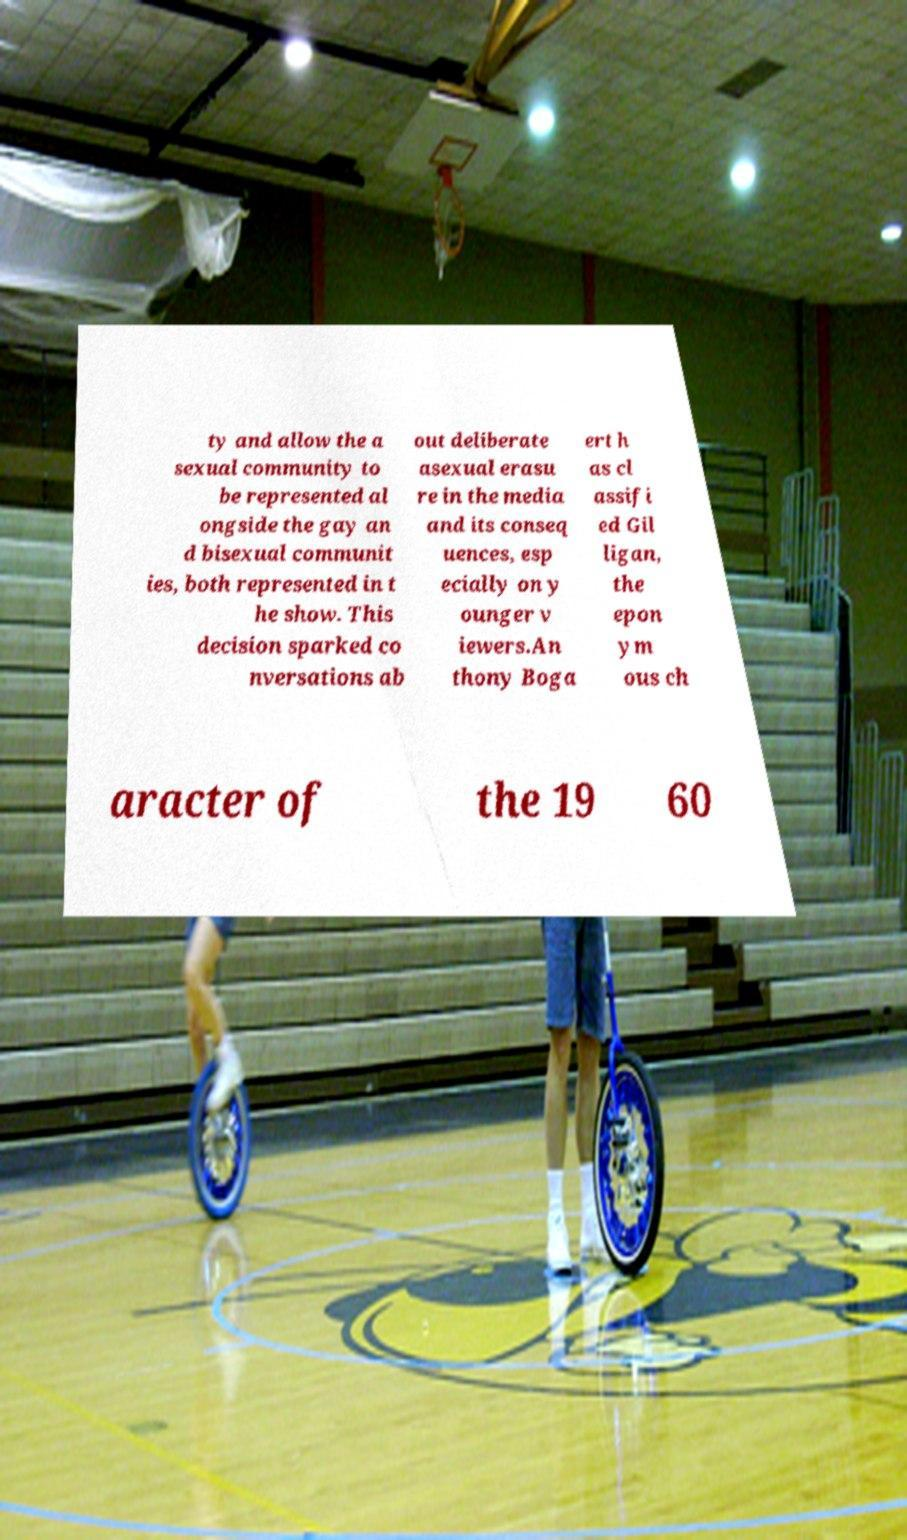What messages or text are displayed in this image? I need them in a readable, typed format. ty and allow the a sexual community to be represented al ongside the gay an d bisexual communit ies, both represented in t he show. This decision sparked co nversations ab out deliberate asexual erasu re in the media and its conseq uences, esp ecially on y ounger v iewers.An thony Boga ert h as cl assifi ed Gil ligan, the epon ym ous ch aracter of the 19 60 